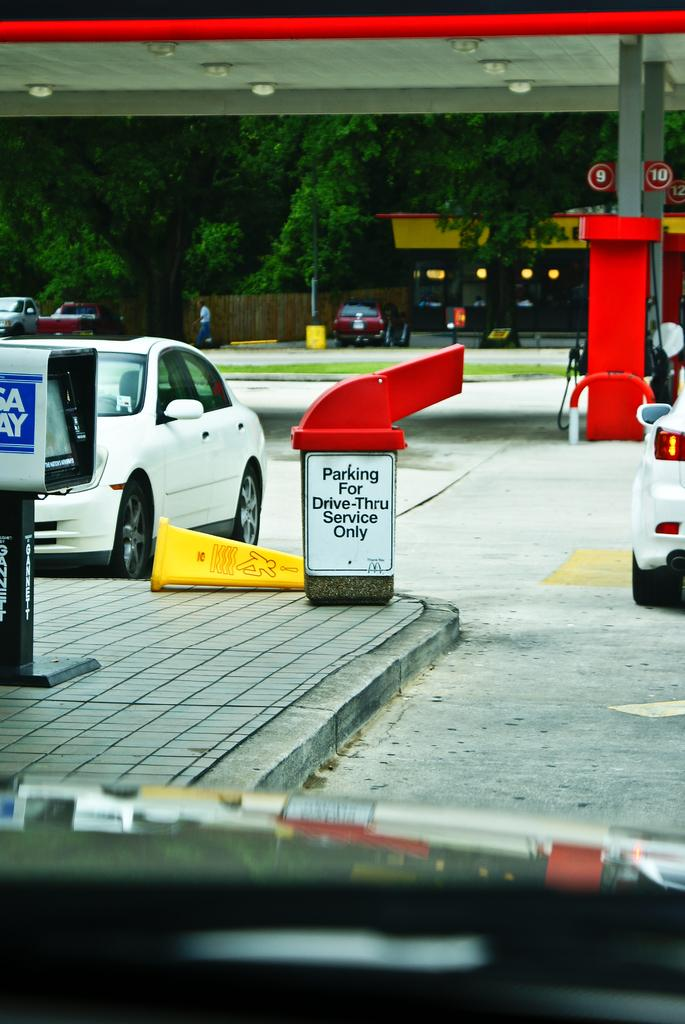<image>
Summarize the visual content of the image. A trash can with a sign that says Parking for Drive-Thru Service Only on it. 